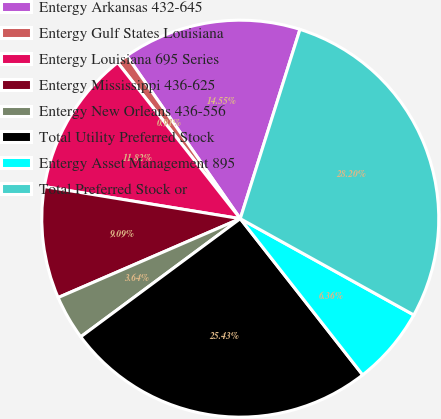Convert chart to OTSL. <chart><loc_0><loc_0><loc_500><loc_500><pie_chart><fcel>Entergy Arkansas 432-645<fcel>Entergy Gulf States Louisiana<fcel>Entergy Louisiana 695 Series<fcel>Entergy Mississippi 436-625<fcel>Entergy New Orleans 436-556<fcel>Total Utility Preferred Stock<fcel>Entergy Asset Management 895<fcel>Total Preferred Stock or<nl><fcel>14.55%<fcel>0.91%<fcel>11.82%<fcel>9.09%<fcel>3.64%<fcel>25.43%<fcel>6.36%<fcel>28.2%<nl></chart> 